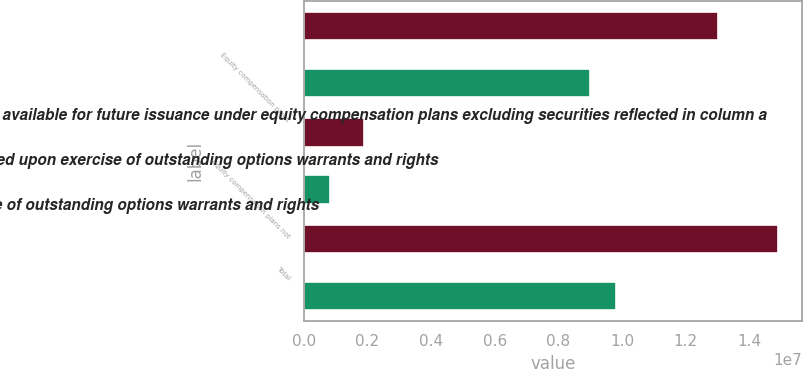Convert chart to OTSL. <chart><loc_0><loc_0><loc_500><loc_500><stacked_bar_chart><ecel><fcel>Equity compensation plans<fcel>Equity compensation plans not<fcel>Total<nl><fcel>c Number of securities remaining available for future issuance under equity compensation plans excluding securities reflected in column a<fcel>1.30083e+07<fcel>1.90125e+06<fcel>1.49095e+07<nl><fcel>a Number of securities to be issued upon exercise of outstanding options warrants and rights<fcel>31.74<fcel>40.22<fcel>32.82<nl><fcel>b Weightedaverage exercise price of outstanding options warrants and rights<fcel>8.99594e+06<fcel>811190<fcel>9.80713e+06<nl></chart> 